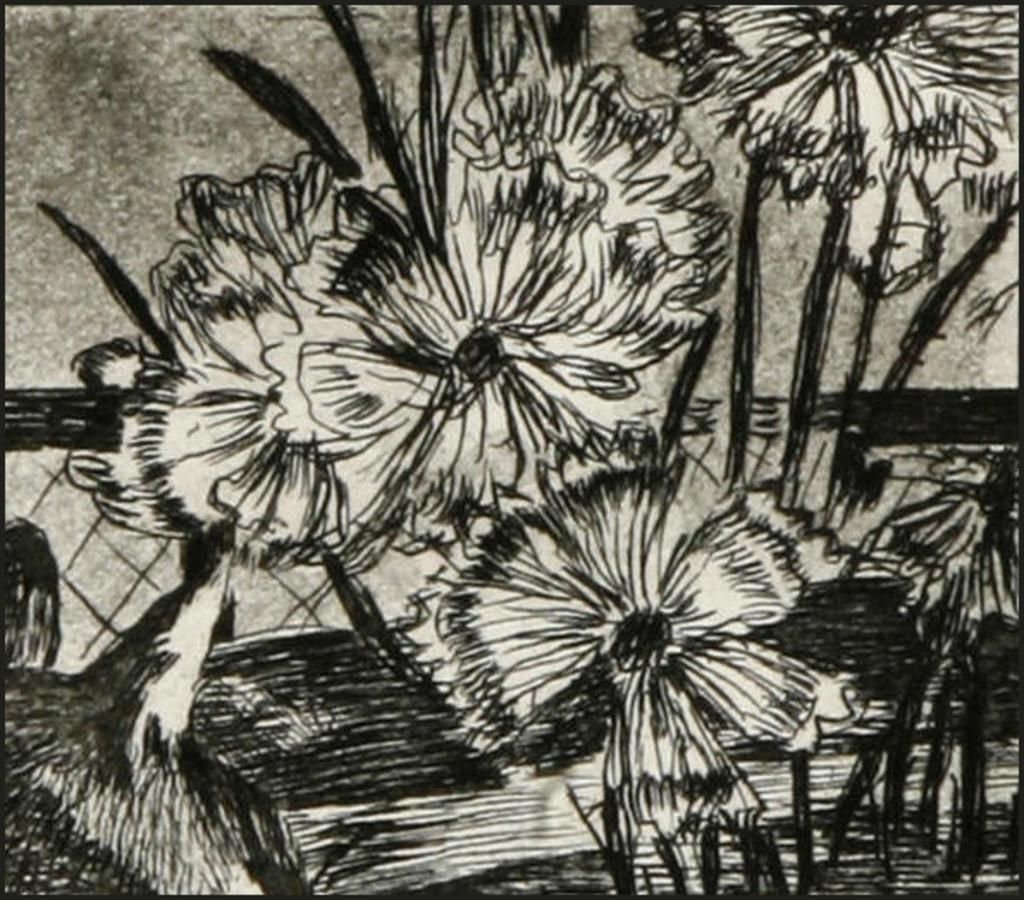What is the main subject of the image? There is a painting in the image. What is the painting depicting? The painting appears to depict flowers. What type of pickle is being used in the painting? There is no pickle present in the painting; it depicts flowers. How does the mother interact with the painting in the image? There is no indication of a mother or any person interacting with the painting in the image. 